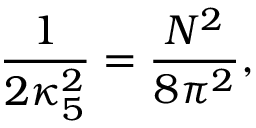<formula> <loc_0><loc_0><loc_500><loc_500>\frac { 1 } { 2 \kappa _ { 5 } ^ { 2 } } = \frac { N ^ { 2 } } { 8 \pi ^ { 2 } } ,</formula> 